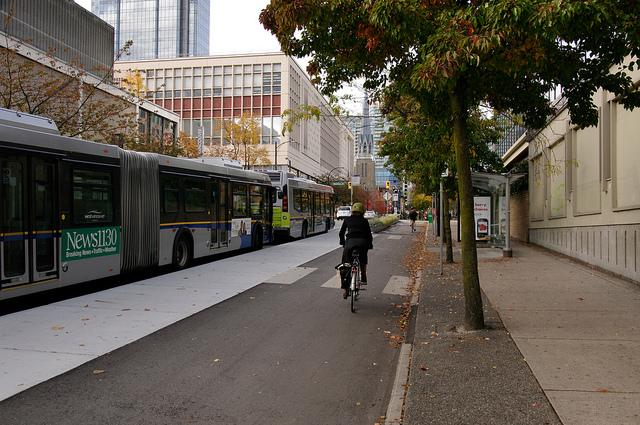What type of lane is shown?

Choices:
A) fire
B) middle
C) passing
D) bike bike 